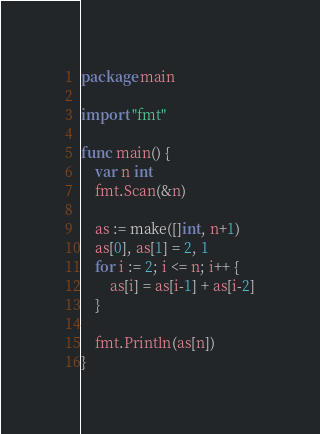Convert code to text. <code><loc_0><loc_0><loc_500><loc_500><_Go_>package main

import "fmt"

func main() {
	var n int
	fmt.Scan(&n)

	as := make([]int, n+1)
	as[0], as[1] = 2, 1
	for i := 2; i <= n; i++ {
		as[i] = as[i-1] + as[i-2]
	}

	fmt.Println(as[n])
}
</code> 